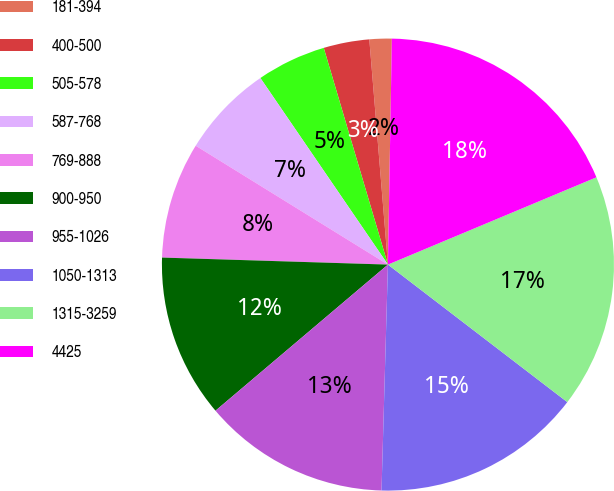Convert chart. <chart><loc_0><loc_0><loc_500><loc_500><pie_chart><fcel>181-394<fcel>400-500<fcel>505-578<fcel>587-768<fcel>769-888<fcel>900-950<fcel>955-1026<fcel>1050-1313<fcel>1315-3259<fcel>4425<nl><fcel>1.59%<fcel>3.27%<fcel>4.96%<fcel>6.64%<fcel>8.32%<fcel>11.68%<fcel>13.36%<fcel>15.04%<fcel>16.72%<fcel>18.41%<nl></chart> 